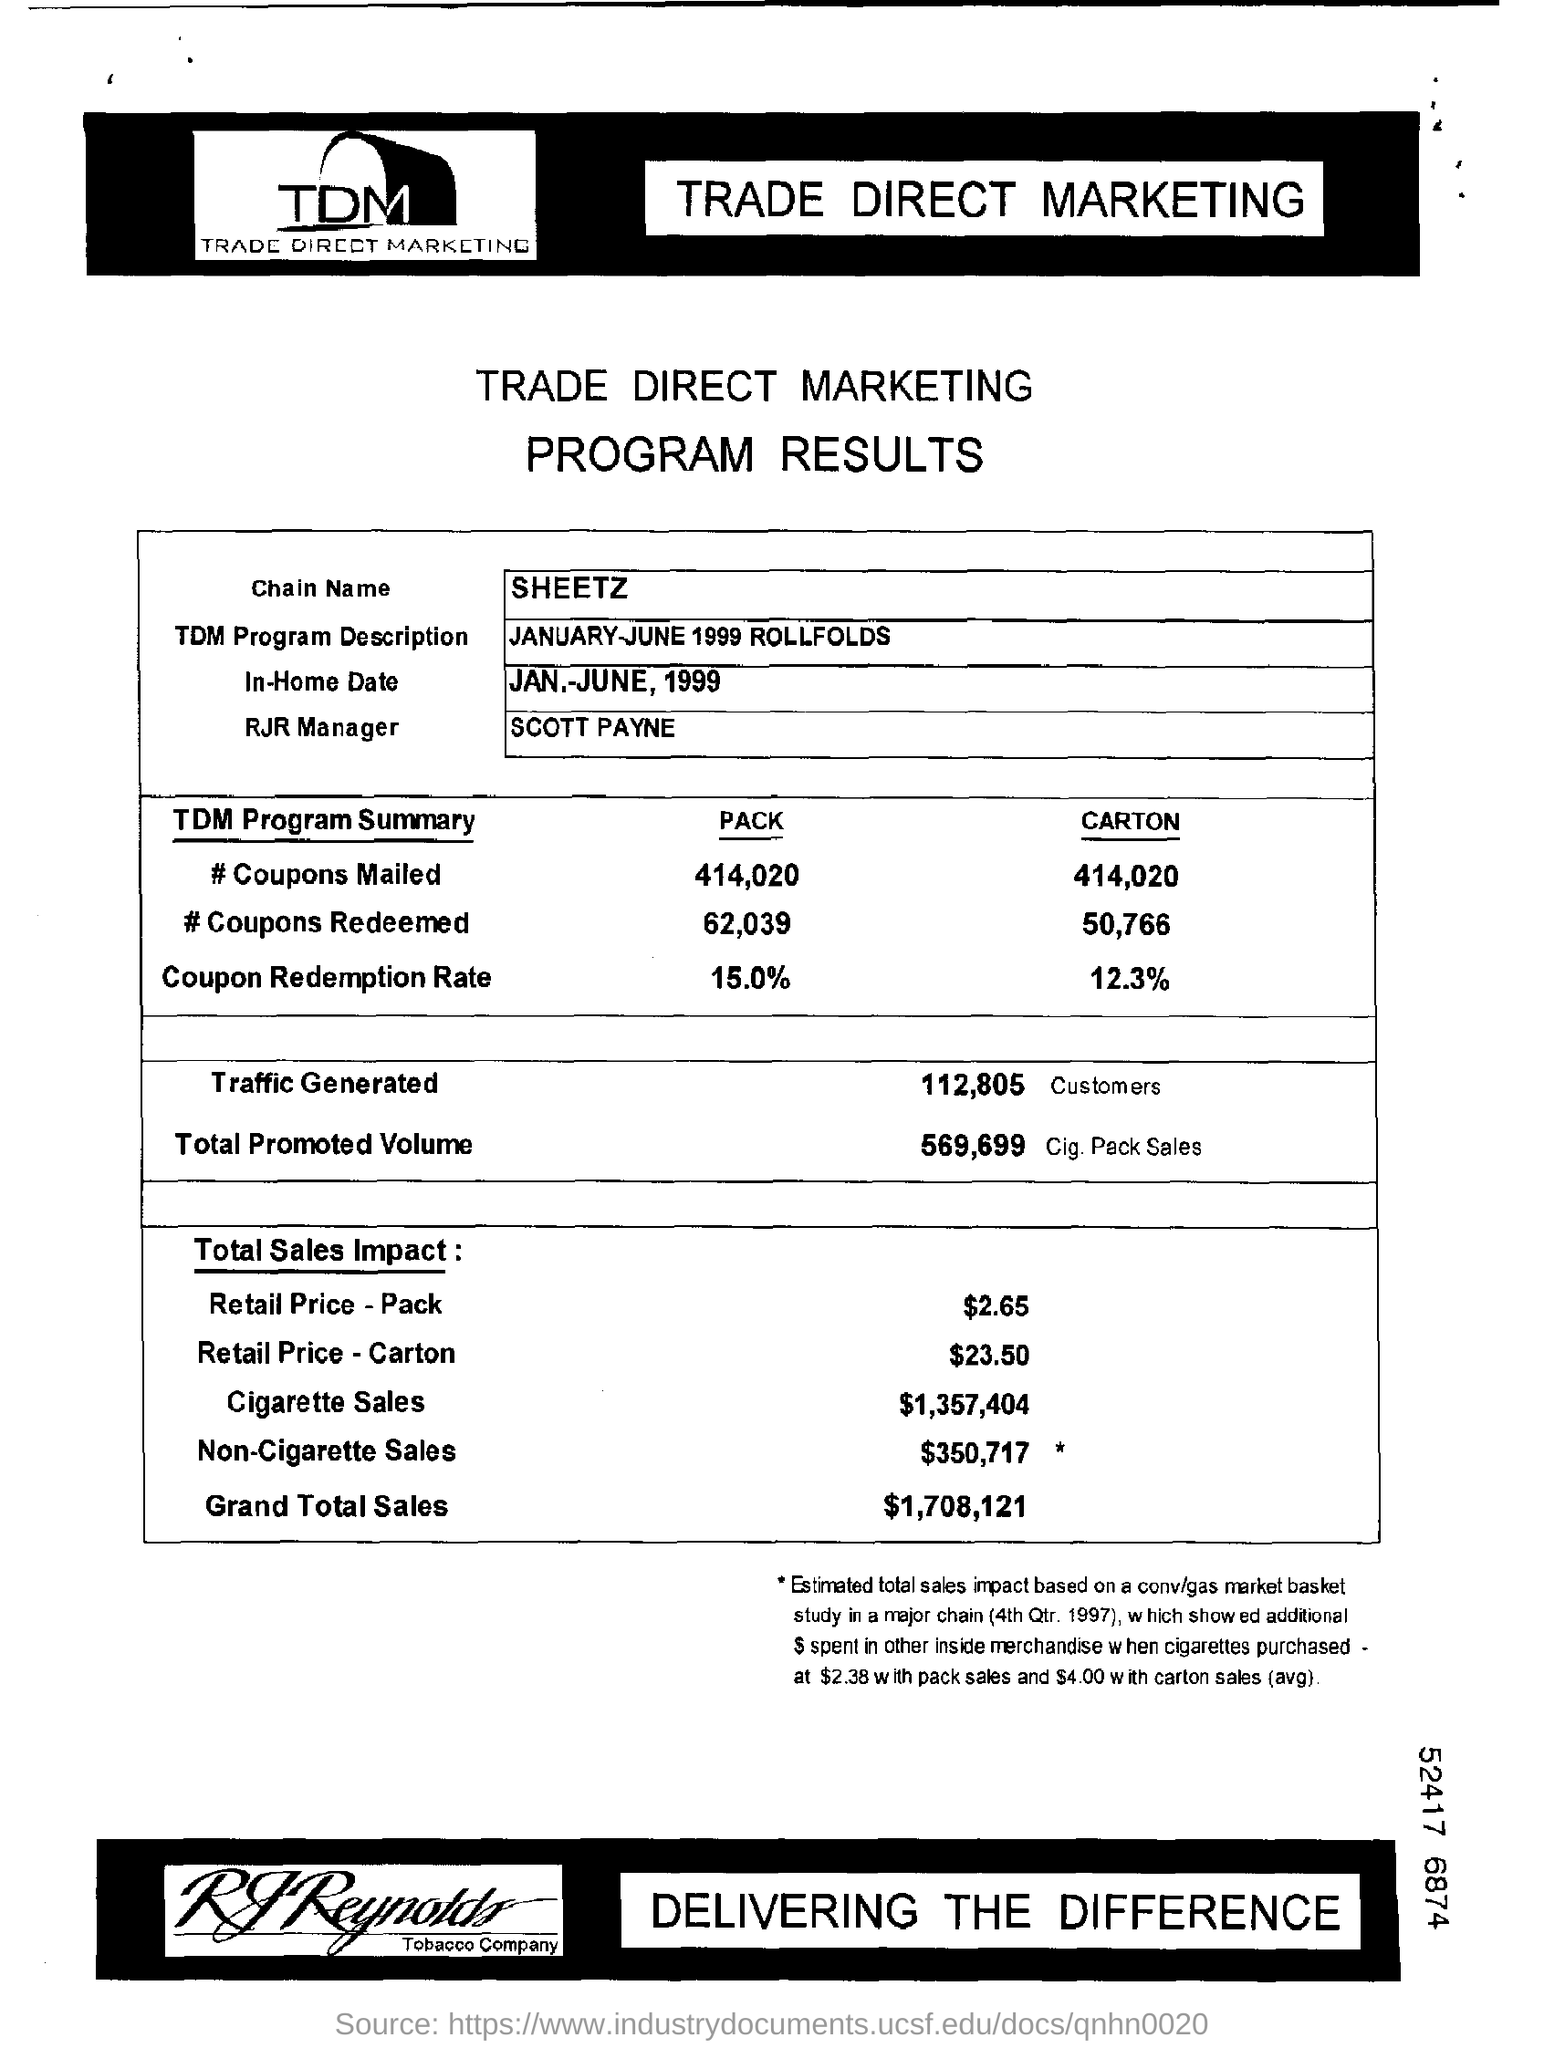What is the Chain name?
Make the answer very short. Sheetz. What is the TDM Program Description?
Your answer should be compact. January-June 1999 Rollfolds. What is the In-Home Date?
Give a very brief answer. JAN.-JUNE, 1999. Who is the RJR Manager?
Give a very brief answer. Scott Payne. How many pack of # coupons mailed?
Make the answer very short. 414,020. How many pack of # coupons redeemed?
Provide a succinct answer. 62,039. How many pack of coupon redemption rate?
Your answer should be compact. 15.0%. How many Carton of # coupons mailed?
Your answer should be very brief. 414,020. How many Carton of # coupons Redeemed?
Your response must be concise. 50,766. How many Carton of coupons redemption Rate?
Your answer should be very brief. 12.3%. 